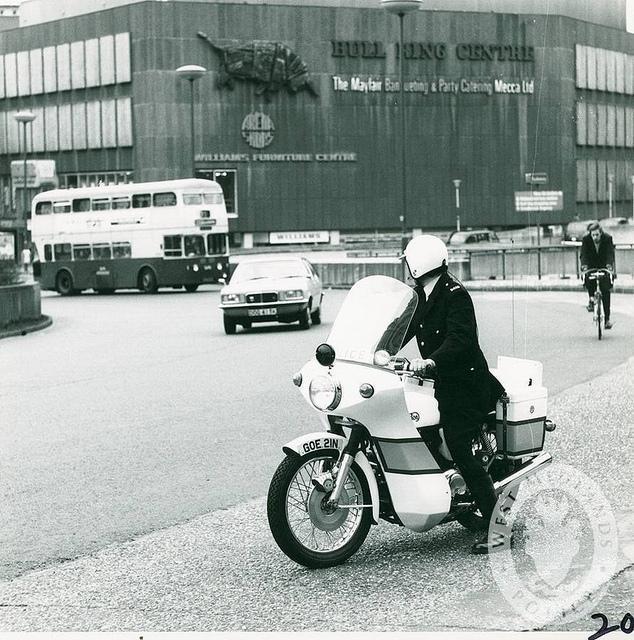How many people are there?
Give a very brief answer. 2. How many toothbrushes does the boy have?
Give a very brief answer. 0. 